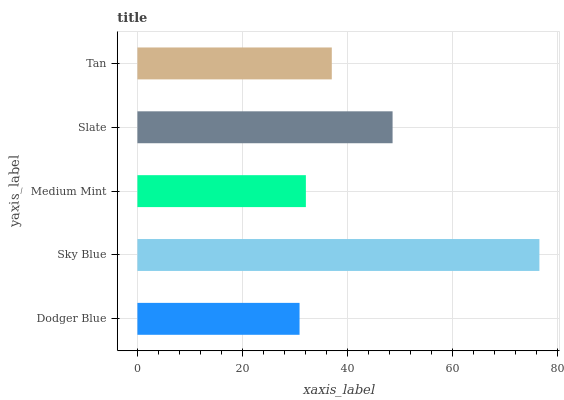Is Dodger Blue the minimum?
Answer yes or no. Yes. Is Sky Blue the maximum?
Answer yes or no. Yes. Is Medium Mint the minimum?
Answer yes or no. No. Is Medium Mint the maximum?
Answer yes or no. No. Is Sky Blue greater than Medium Mint?
Answer yes or no. Yes. Is Medium Mint less than Sky Blue?
Answer yes or no. Yes. Is Medium Mint greater than Sky Blue?
Answer yes or no. No. Is Sky Blue less than Medium Mint?
Answer yes or no. No. Is Tan the high median?
Answer yes or no. Yes. Is Tan the low median?
Answer yes or no. Yes. Is Medium Mint the high median?
Answer yes or no. No. Is Sky Blue the low median?
Answer yes or no. No. 